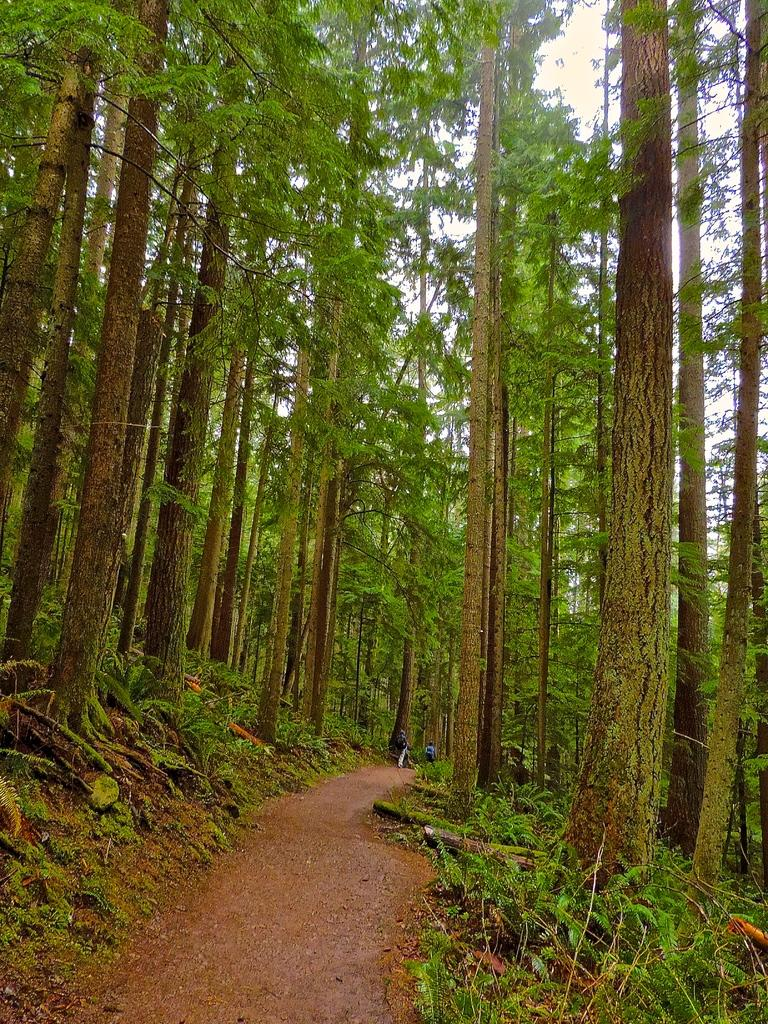What type of road is visible in the image? There is a mud road in the image. What can be seen on the sides of the road? Grasses, plants, and trees are present on the sides of the road. What is visible in the background of the image? The sky is visible in the background of the image. What type of fruit is hanging from the trees on the sides of the road in the image? There is no fruit visible in the image; only trees are present on the sides of the road. What statement can be made about the road in the image? The statement that the road is made of mud can be made about the road in the image. 